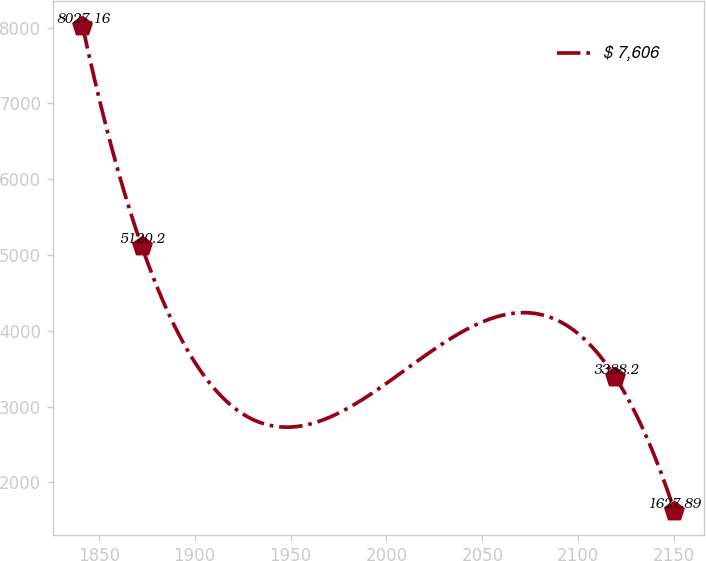<chart> <loc_0><loc_0><loc_500><loc_500><line_chart><ecel><fcel>$ 7,606<nl><fcel>1841.49<fcel>8027.16<nl><fcel>1872.33<fcel>5120.2<nl><fcel>2119.3<fcel>3388.2<nl><fcel>2150.14<fcel>1627.89<nl></chart> 